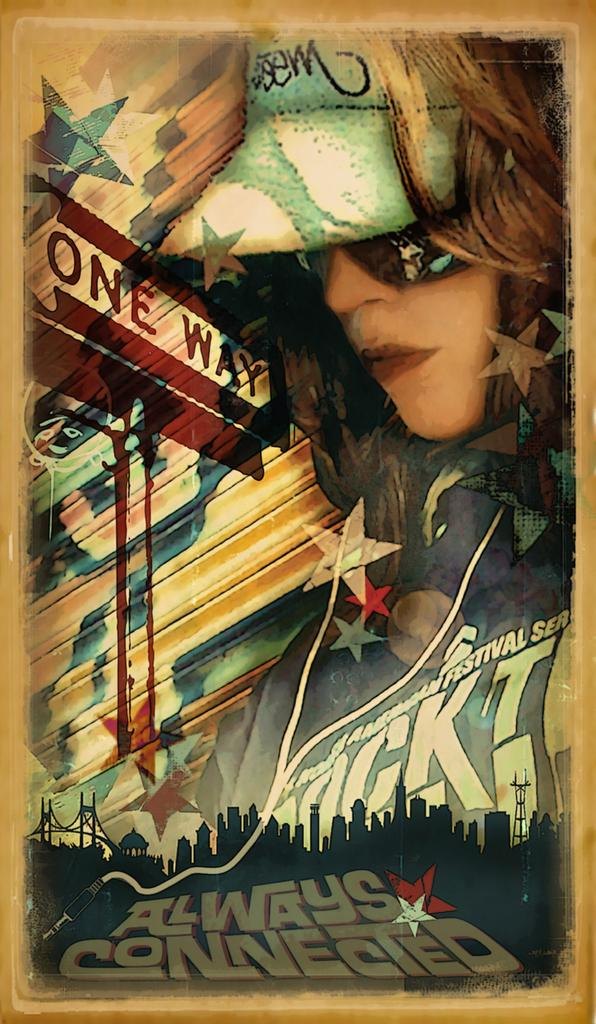What is present in the image that features an image or design? There is a poster in the image. What can be seen in the image on the poster? The poster contains an image of a person. What else is present on the poster besides the image? There is text written on the poster. What type of chalk is being used to write on the poster in the image? There is no chalk present in the image, and no writing is being done on the poster. 